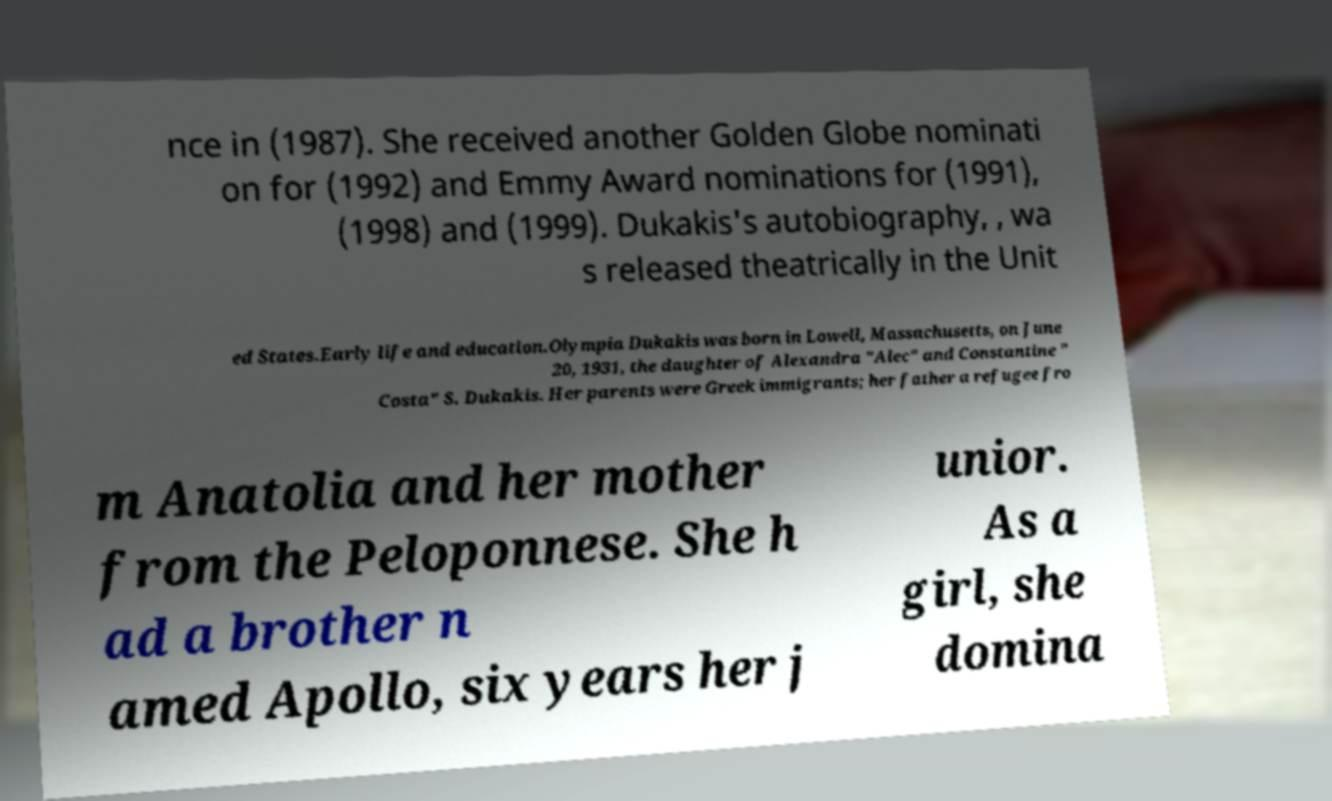Could you extract and type out the text from this image? nce in (1987). She received another Golden Globe nominati on for (1992) and Emmy Award nominations for (1991), (1998) and (1999). Dukakis's autobiography, , wa s released theatrically in the Unit ed States.Early life and education.Olympia Dukakis was born in Lowell, Massachusetts, on June 20, 1931, the daughter of Alexandra "Alec" and Constantine " Costa" S. Dukakis. Her parents were Greek immigrants; her father a refugee fro m Anatolia and her mother from the Peloponnese. She h ad a brother n amed Apollo, six years her j unior. As a girl, she domina 